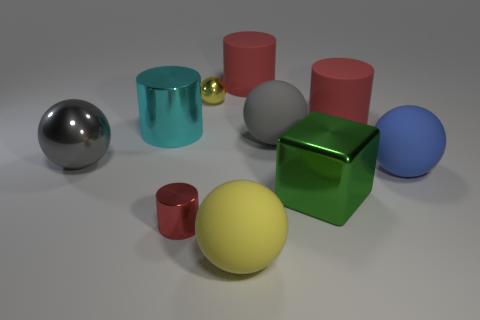Subtract all red cylinders. How many were subtracted if there are1red cylinders left? 2 Subtract all red blocks. How many red cylinders are left? 3 Subtract all large shiny cylinders. How many cylinders are left? 3 Subtract 1 spheres. How many spheres are left? 4 Subtract all gray spheres. How many spheres are left? 3 Subtract all purple cylinders. Subtract all gray spheres. How many cylinders are left? 4 Subtract all green cubes. Subtract all small red cylinders. How many objects are left? 8 Add 9 large green things. How many large green things are left? 10 Add 3 blue matte spheres. How many blue matte spheres exist? 4 Subtract 0 blue cylinders. How many objects are left? 10 